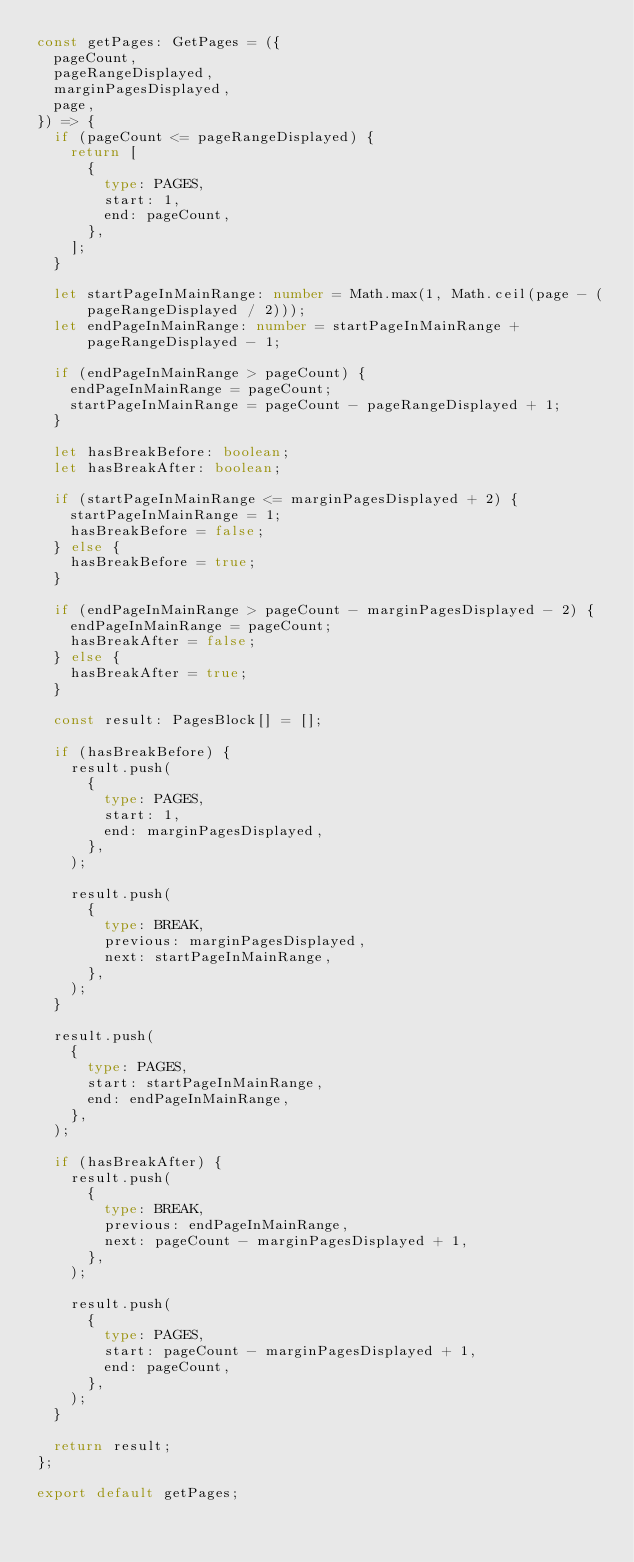Convert code to text. <code><loc_0><loc_0><loc_500><loc_500><_TypeScript_>const getPages: GetPages = ({
  pageCount,
  pageRangeDisplayed,
  marginPagesDisplayed,
  page,
}) => {
  if (pageCount <= pageRangeDisplayed) {
    return [
      {
        type: PAGES,
        start: 1,
        end: pageCount,
      },
    ];
  }

  let startPageInMainRange: number = Math.max(1, Math.ceil(page - (pageRangeDisplayed / 2)));
  let endPageInMainRange: number = startPageInMainRange + pageRangeDisplayed - 1;

  if (endPageInMainRange > pageCount) {
    endPageInMainRange = pageCount;
    startPageInMainRange = pageCount - pageRangeDisplayed + 1;
  }

  let hasBreakBefore: boolean;
  let hasBreakAfter: boolean;

  if (startPageInMainRange <= marginPagesDisplayed + 2) {
    startPageInMainRange = 1;
    hasBreakBefore = false;
  } else {
    hasBreakBefore = true;
  }

  if (endPageInMainRange > pageCount - marginPagesDisplayed - 2) {
    endPageInMainRange = pageCount;
    hasBreakAfter = false;
  } else {
    hasBreakAfter = true;
  }

  const result: PagesBlock[] = [];

  if (hasBreakBefore) {
    result.push(
      {
        type: PAGES,
        start: 1,
        end: marginPagesDisplayed,
      },
    );

    result.push(
      {
        type: BREAK,
        previous: marginPagesDisplayed,
        next: startPageInMainRange,
      },
    );
  }

  result.push(
    {
      type: PAGES,
      start: startPageInMainRange,
      end: endPageInMainRange,
    },
  );

  if (hasBreakAfter) {
    result.push(
      {
        type: BREAK,
        previous: endPageInMainRange,
        next: pageCount - marginPagesDisplayed + 1,
      },
    );

    result.push(
      {
        type: PAGES,
        start: pageCount - marginPagesDisplayed + 1,
        end: pageCount,
      },
    );
  }

  return result;
};

export default getPages;
</code> 